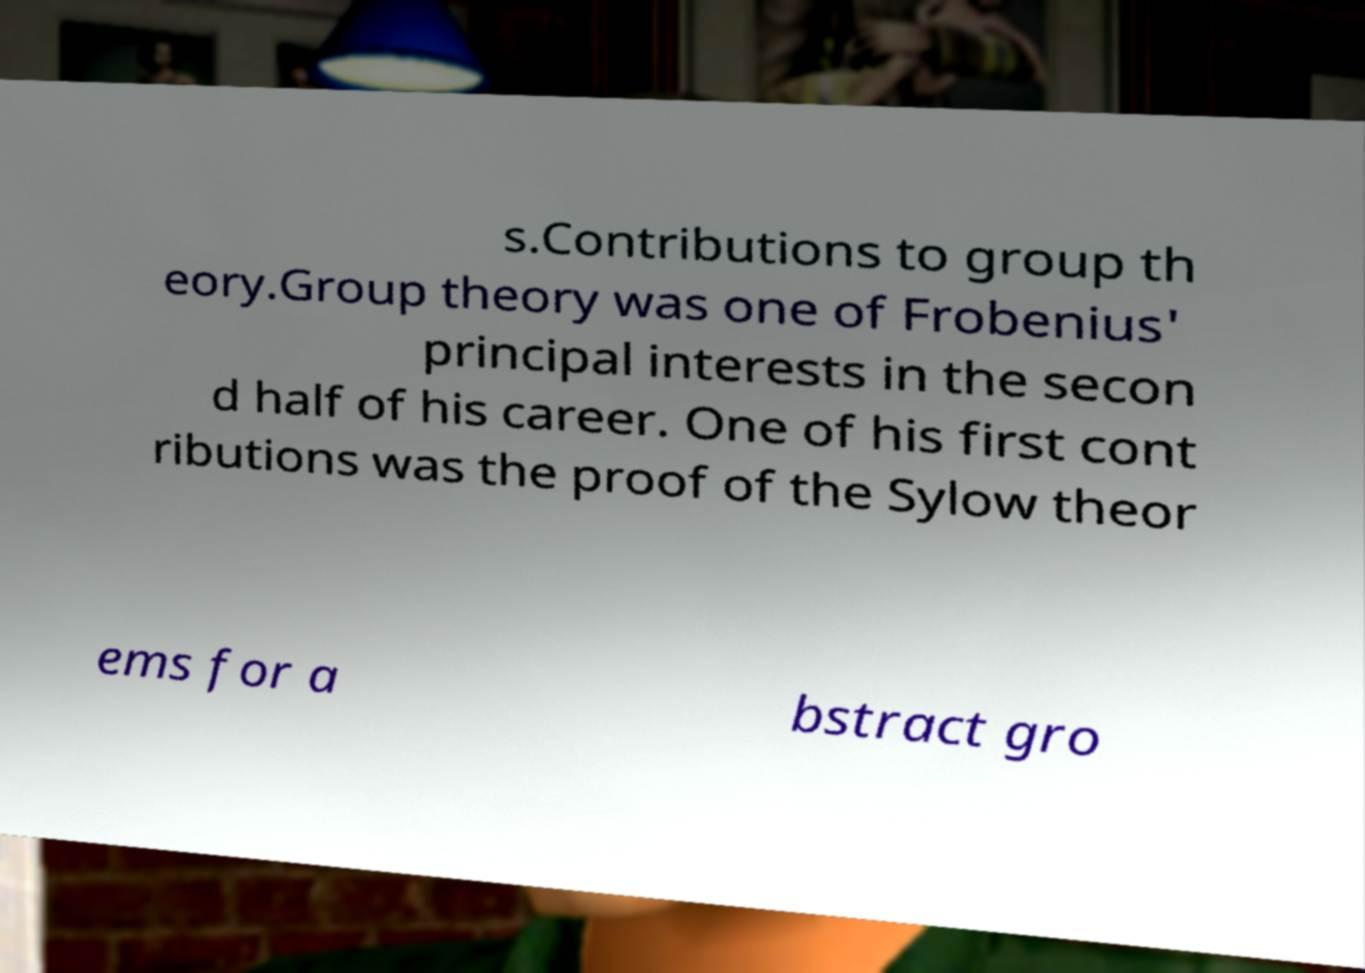Can you accurately transcribe the text from the provided image for me? s.Contributions to group th eory.Group theory was one of Frobenius' principal interests in the secon d half of his career. One of his first cont ributions was the proof of the Sylow theor ems for a bstract gro 